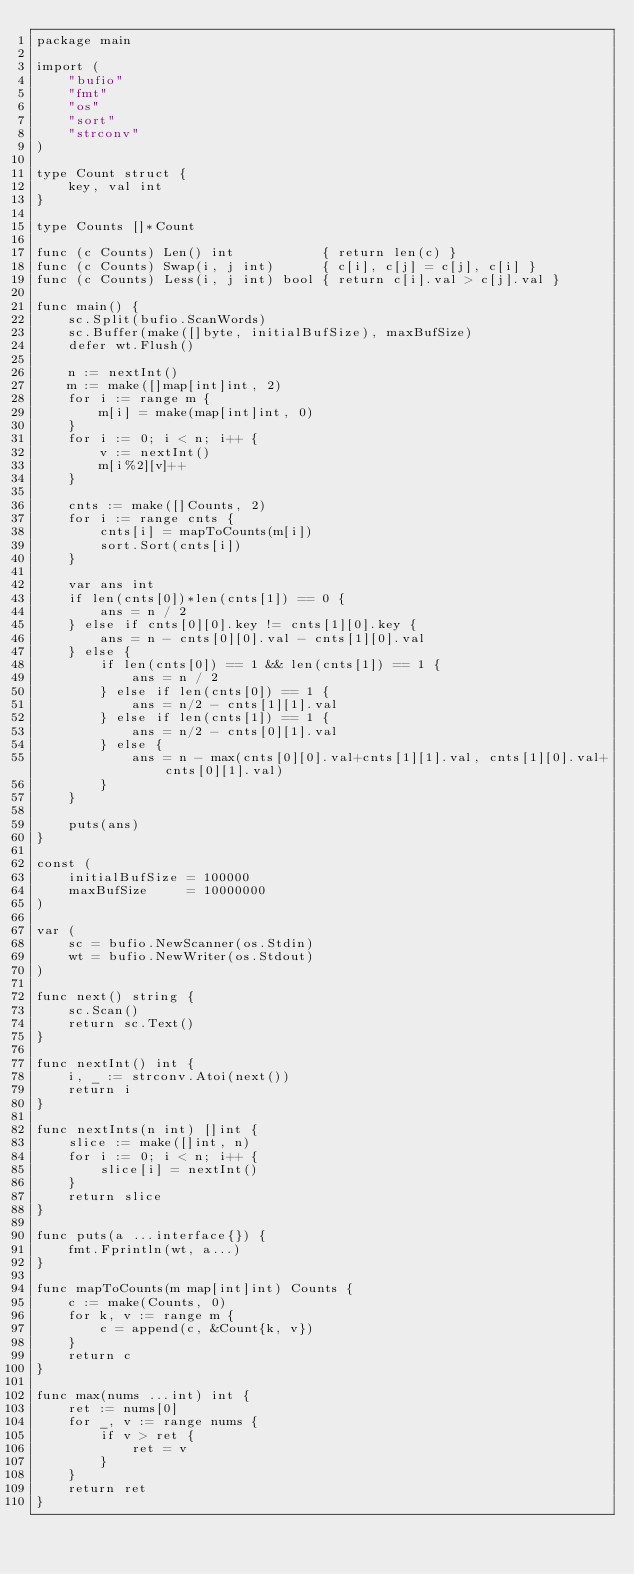<code> <loc_0><loc_0><loc_500><loc_500><_Go_>package main

import (
	"bufio"
	"fmt"
	"os"
	"sort"
	"strconv"
)

type Count struct {
	key, val int
}

type Counts []*Count

func (c Counts) Len() int           { return len(c) }
func (c Counts) Swap(i, j int)      { c[i], c[j] = c[j], c[i] }
func (c Counts) Less(i, j int) bool { return c[i].val > c[j].val }

func main() {
	sc.Split(bufio.ScanWords)
	sc.Buffer(make([]byte, initialBufSize), maxBufSize)
	defer wt.Flush()

	n := nextInt()
	m := make([]map[int]int, 2)
	for i := range m {
		m[i] = make(map[int]int, 0)
	}
	for i := 0; i < n; i++ {
		v := nextInt()
		m[i%2][v]++
	}

	cnts := make([]Counts, 2)
	for i := range cnts {
		cnts[i] = mapToCounts(m[i])
		sort.Sort(cnts[i])
	}

	var ans int
	if len(cnts[0])*len(cnts[1]) == 0 {
		ans = n / 2
	} else if cnts[0][0].key != cnts[1][0].key {
		ans = n - cnts[0][0].val - cnts[1][0].val
	} else {
		if len(cnts[0]) == 1 && len(cnts[1]) == 1 {
			ans = n / 2
		} else if len(cnts[0]) == 1 {
			ans = n/2 - cnts[1][1].val
		} else if len(cnts[1]) == 1 {
			ans = n/2 - cnts[0][1].val
		} else {
			ans = n - max(cnts[0][0].val+cnts[1][1].val, cnts[1][0].val+cnts[0][1].val)
		}
	}

	puts(ans)
}

const (
	initialBufSize = 100000
	maxBufSize     = 10000000
)

var (
	sc = bufio.NewScanner(os.Stdin)
	wt = bufio.NewWriter(os.Stdout)
)

func next() string {
	sc.Scan()
	return sc.Text()
}

func nextInt() int {
	i, _ := strconv.Atoi(next())
	return i
}

func nextInts(n int) []int {
	slice := make([]int, n)
	for i := 0; i < n; i++ {
		slice[i] = nextInt()
	}
	return slice
}

func puts(a ...interface{}) {
	fmt.Fprintln(wt, a...)
}

func mapToCounts(m map[int]int) Counts {
	c := make(Counts, 0)
	for k, v := range m {
		c = append(c, &Count{k, v})
	}
	return c
}

func max(nums ...int) int {
	ret := nums[0]
	for _, v := range nums {
		if v > ret {
			ret = v
		}
	}
	return ret
}
</code> 